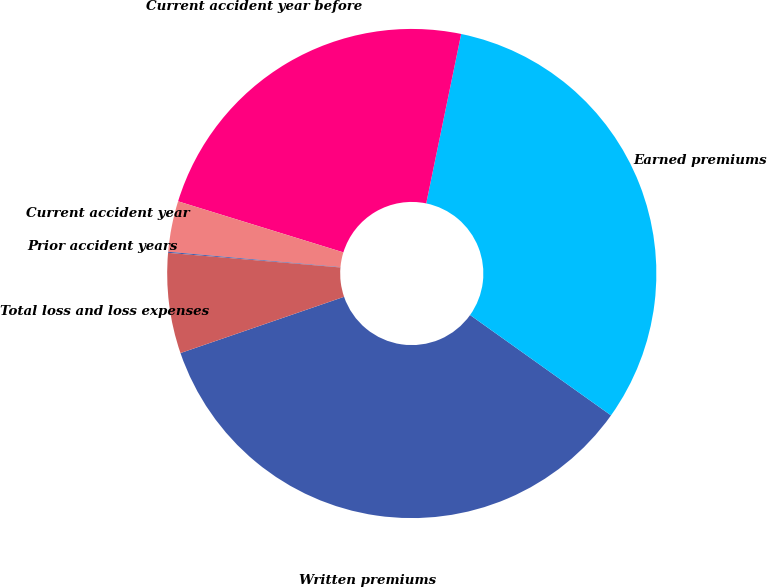<chart> <loc_0><loc_0><loc_500><loc_500><pie_chart><fcel>Written premiums<fcel>Earned premiums<fcel>Current accident year before<fcel>Current accident year<fcel>Prior accident years<fcel>Total loss and loss expenses<nl><fcel>34.88%<fcel>31.61%<fcel>23.47%<fcel>3.35%<fcel>0.07%<fcel>6.62%<nl></chart> 